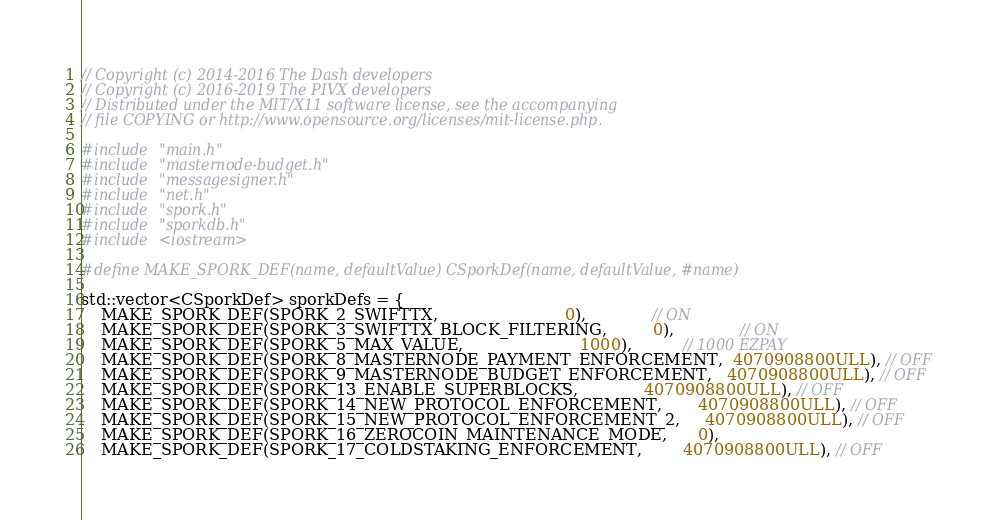Convert code to text. <code><loc_0><loc_0><loc_500><loc_500><_C++_>// Copyright (c) 2014-2016 The Dash developers
// Copyright (c) 2016-2019 The PIVX developers
// Distributed under the MIT/X11 software license, see the accompanying
// file COPYING or http://www.opensource.org/licenses/mit-license.php.

#include "main.h"
#include "masternode-budget.h"
#include "messagesigner.h"
#include "net.h"
#include "spork.h"
#include "sporkdb.h"
#include <iostream>

#define MAKE_SPORK_DEF(name, defaultValue) CSporkDef(name, defaultValue, #name)

std::vector<CSporkDef> sporkDefs = {
    MAKE_SPORK_DEF(SPORK_2_SWIFTTX,                         0),             // ON
    MAKE_SPORK_DEF(SPORK_3_SWIFTTX_BLOCK_FILTERING,         0),             // ON
    MAKE_SPORK_DEF(SPORK_5_MAX_VALUE,                       1000),          // 1000 EZPAY
    MAKE_SPORK_DEF(SPORK_8_MASTERNODE_PAYMENT_ENFORCEMENT,  4070908800ULL), // OFF
    MAKE_SPORK_DEF(SPORK_9_MASTERNODE_BUDGET_ENFORCEMENT,   4070908800ULL), // OFF
    MAKE_SPORK_DEF(SPORK_13_ENABLE_SUPERBLOCKS,             4070908800ULL), // OFF
    MAKE_SPORK_DEF(SPORK_14_NEW_PROTOCOL_ENFORCEMENT,       4070908800ULL), // OFF
    MAKE_SPORK_DEF(SPORK_15_NEW_PROTOCOL_ENFORCEMENT_2,     4070908800ULL), // OFF
    MAKE_SPORK_DEF(SPORK_16_ZEROCOIN_MAINTENANCE_MODE,      0),
    MAKE_SPORK_DEF(SPORK_17_COLDSTAKING_ENFORCEMENT,        4070908800ULL), // OFF</code> 